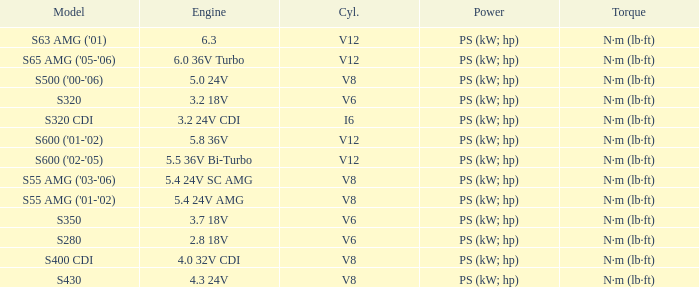Which Torque has a Model of s63 amg ('01)? N·m (lb·ft). 